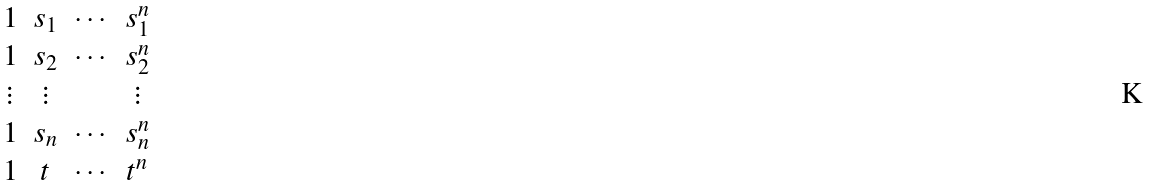Convert formula to latex. <formula><loc_0><loc_0><loc_500><loc_500>\begin{matrix} 1 & s _ { 1 } & \cdots & s _ { 1 } ^ { n } \\ 1 & s _ { 2 } & \cdots & s _ { 2 } ^ { n } \\ \vdots & \vdots & & \vdots \\ 1 & s _ { n } & \cdots & s _ { n } ^ { n } \\ 1 & t & \cdots & t ^ { n } \\ \end{matrix}</formula> 